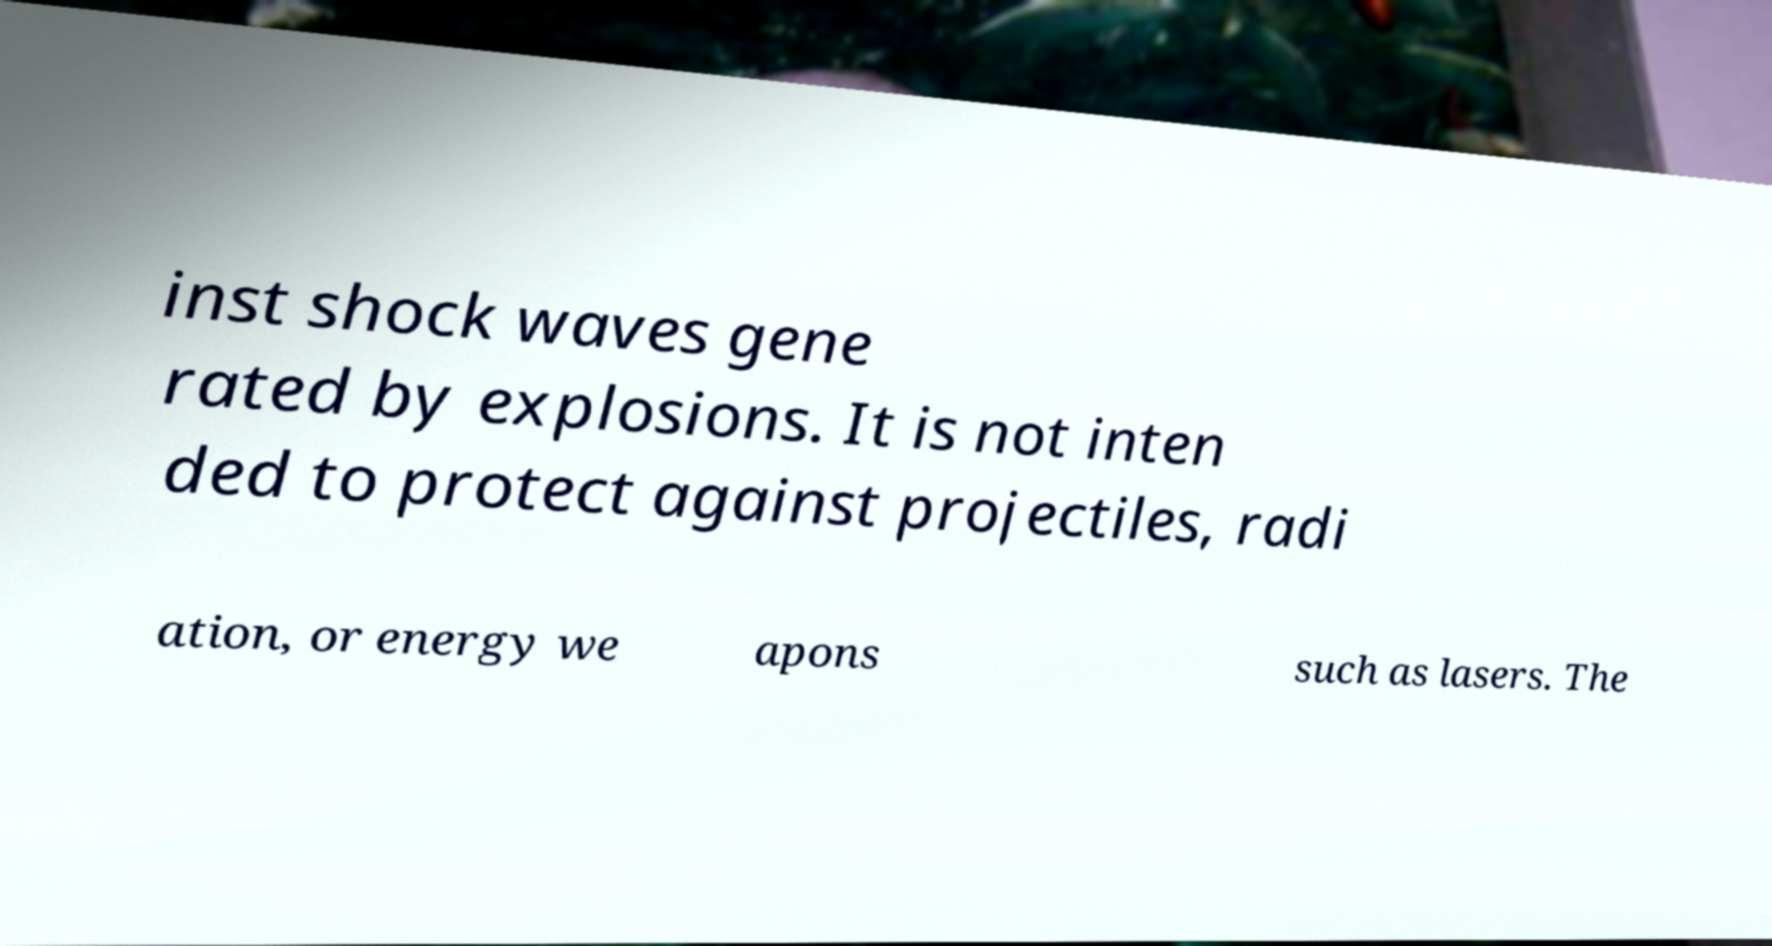Please read and relay the text visible in this image. What does it say? inst shock waves gene rated by explosions. It is not inten ded to protect against projectiles, radi ation, or energy we apons such as lasers. The 